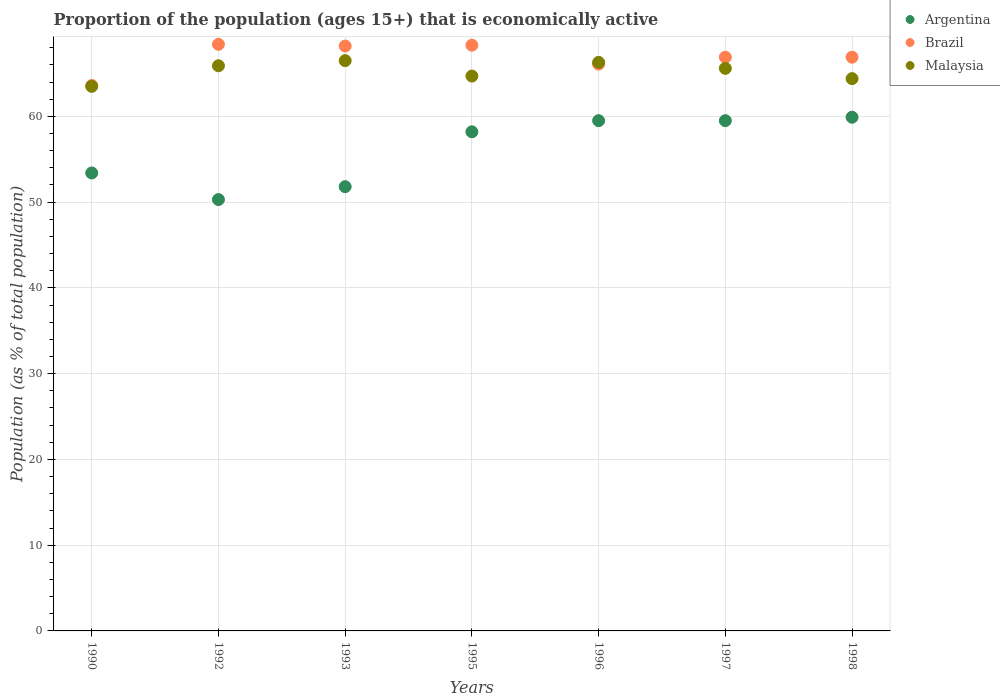Is the number of dotlines equal to the number of legend labels?
Give a very brief answer. Yes. What is the proportion of the population that is economically active in Malaysia in 1995?
Offer a terse response. 64.7. Across all years, what is the maximum proportion of the population that is economically active in Brazil?
Provide a short and direct response. 68.4. Across all years, what is the minimum proportion of the population that is economically active in Brazil?
Offer a very short reply. 63.6. In which year was the proportion of the population that is economically active in Malaysia minimum?
Make the answer very short. 1990. What is the total proportion of the population that is economically active in Brazil in the graph?
Your answer should be compact. 468.4. What is the difference between the proportion of the population that is economically active in Argentina in 1990 and that in 1995?
Your answer should be compact. -4.8. What is the difference between the proportion of the population that is economically active in Malaysia in 1993 and the proportion of the population that is economically active in Argentina in 1990?
Provide a succinct answer. 13.1. What is the average proportion of the population that is economically active in Brazil per year?
Offer a terse response. 66.91. In the year 1995, what is the difference between the proportion of the population that is economically active in Brazil and proportion of the population that is economically active in Malaysia?
Provide a succinct answer. 3.6. In how many years, is the proportion of the population that is economically active in Argentina greater than 64 %?
Offer a terse response. 0. What is the ratio of the proportion of the population that is economically active in Argentina in 1995 to that in 1996?
Give a very brief answer. 0.98. Is the difference between the proportion of the population that is economically active in Brazil in 1995 and 1996 greater than the difference between the proportion of the population that is economically active in Malaysia in 1995 and 1996?
Offer a terse response. Yes. What is the difference between the highest and the second highest proportion of the population that is economically active in Malaysia?
Keep it short and to the point. 0.2. Is it the case that in every year, the sum of the proportion of the population that is economically active in Malaysia and proportion of the population that is economically active in Argentina  is greater than the proportion of the population that is economically active in Brazil?
Your response must be concise. Yes. Does the proportion of the population that is economically active in Argentina monotonically increase over the years?
Your answer should be compact. No. Is the proportion of the population that is economically active in Malaysia strictly greater than the proportion of the population that is economically active in Argentina over the years?
Give a very brief answer. Yes. How many dotlines are there?
Make the answer very short. 3. Does the graph contain any zero values?
Offer a very short reply. No. How many legend labels are there?
Ensure brevity in your answer.  3. What is the title of the graph?
Make the answer very short. Proportion of the population (ages 15+) that is economically active. What is the label or title of the Y-axis?
Ensure brevity in your answer.  Population (as % of total population). What is the Population (as % of total population) in Argentina in 1990?
Make the answer very short. 53.4. What is the Population (as % of total population) of Brazil in 1990?
Keep it short and to the point. 63.6. What is the Population (as % of total population) in Malaysia in 1990?
Ensure brevity in your answer.  63.5. What is the Population (as % of total population) of Argentina in 1992?
Provide a short and direct response. 50.3. What is the Population (as % of total population) in Brazil in 1992?
Provide a succinct answer. 68.4. What is the Population (as % of total population) in Malaysia in 1992?
Offer a very short reply. 65.9. What is the Population (as % of total population) of Argentina in 1993?
Provide a succinct answer. 51.8. What is the Population (as % of total population) of Brazil in 1993?
Your answer should be very brief. 68.2. What is the Population (as % of total population) of Malaysia in 1993?
Provide a succinct answer. 66.5. What is the Population (as % of total population) in Argentina in 1995?
Ensure brevity in your answer.  58.2. What is the Population (as % of total population) of Brazil in 1995?
Give a very brief answer. 68.3. What is the Population (as % of total population) of Malaysia in 1995?
Give a very brief answer. 64.7. What is the Population (as % of total population) of Argentina in 1996?
Keep it short and to the point. 59.5. What is the Population (as % of total population) of Brazil in 1996?
Offer a terse response. 66.1. What is the Population (as % of total population) in Malaysia in 1996?
Make the answer very short. 66.3. What is the Population (as % of total population) in Argentina in 1997?
Provide a short and direct response. 59.5. What is the Population (as % of total population) in Brazil in 1997?
Your response must be concise. 66.9. What is the Population (as % of total population) in Malaysia in 1997?
Ensure brevity in your answer.  65.6. What is the Population (as % of total population) in Argentina in 1998?
Keep it short and to the point. 59.9. What is the Population (as % of total population) in Brazil in 1998?
Your response must be concise. 66.9. What is the Population (as % of total population) in Malaysia in 1998?
Provide a succinct answer. 64.4. Across all years, what is the maximum Population (as % of total population) in Argentina?
Give a very brief answer. 59.9. Across all years, what is the maximum Population (as % of total population) of Brazil?
Provide a short and direct response. 68.4. Across all years, what is the maximum Population (as % of total population) of Malaysia?
Ensure brevity in your answer.  66.5. Across all years, what is the minimum Population (as % of total population) in Argentina?
Offer a very short reply. 50.3. Across all years, what is the minimum Population (as % of total population) of Brazil?
Your answer should be very brief. 63.6. Across all years, what is the minimum Population (as % of total population) of Malaysia?
Give a very brief answer. 63.5. What is the total Population (as % of total population) of Argentina in the graph?
Ensure brevity in your answer.  392.6. What is the total Population (as % of total population) of Brazil in the graph?
Provide a short and direct response. 468.4. What is the total Population (as % of total population) in Malaysia in the graph?
Offer a very short reply. 456.9. What is the difference between the Population (as % of total population) of Argentina in 1990 and that in 1992?
Provide a succinct answer. 3.1. What is the difference between the Population (as % of total population) of Brazil in 1990 and that in 1992?
Provide a short and direct response. -4.8. What is the difference between the Population (as % of total population) in Malaysia in 1990 and that in 1992?
Offer a terse response. -2.4. What is the difference between the Population (as % of total population) in Argentina in 1990 and that in 1993?
Your answer should be compact. 1.6. What is the difference between the Population (as % of total population) of Argentina in 1990 and that in 1995?
Your answer should be very brief. -4.8. What is the difference between the Population (as % of total population) in Argentina in 1990 and that in 1996?
Ensure brevity in your answer.  -6.1. What is the difference between the Population (as % of total population) of Argentina in 1990 and that in 1997?
Ensure brevity in your answer.  -6.1. What is the difference between the Population (as % of total population) of Brazil in 1990 and that in 1997?
Your answer should be very brief. -3.3. What is the difference between the Population (as % of total population) of Malaysia in 1990 and that in 1997?
Your response must be concise. -2.1. What is the difference between the Population (as % of total population) of Argentina in 1992 and that in 1993?
Your response must be concise. -1.5. What is the difference between the Population (as % of total population) of Argentina in 1992 and that in 1995?
Offer a very short reply. -7.9. What is the difference between the Population (as % of total population) in Brazil in 1992 and that in 1995?
Ensure brevity in your answer.  0.1. What is the difference between the Population (as % of total population) in Malaysia in 1992 and that in 1995?
Offer a terse response. 1.2. What is the difference between the Population (as % of total population) in Brazil in 1992 and that in 1996?
Offer a very short reply. 2.3. What is the difference between the Population (as % of total population) of Argentina in 1992 and that in 1997?
Your response must be concise. -9.2. What is the difference between the Population (as % of total population) of Brazil in 1992 and that in 1997?
Your response must be concise. 1.5. What is the difference between the Population (as % of total population) of Brazil in 1992 and that in 1998?
Make the answer very short. 1.5. What is the difference between the Population (as % of total population) of Malaysia in 1992 and that in 1998?
Provide a succinct answer. 1.5. What is the difference between the Population (as % of total population) in Argentina in 1993 and that in 1995?
Offer a terse response. -6.4. What is the difference between the Population (as % of total population) of Brazil in 1993 and that in 1995?
Offer a terse response. -0.1. What is the difference between the Population (as % of total population) in Malaysia in 1993 and that in 1995?
Your answer should be very brief. 1.8. What is the difference between the Population (as % of total population) in Argentina in 1993 and that in 1997?
Provide a short and direct response. -7.7. What is the difference between the Population (as % of total population) of Brazil in 1993 and that in 1997?
Keep it short and to the point. 1.3. What is the difference between the Population (as % of total population) of Brazil in 1993 and that in 1998?
Your response must be concise. 1.3. What is the difference between the Population (as % of total population) in Malaysia in 1995 and that in 1996?
Offer a very short reply. -1.6. What is the difference between the Population (as % of total population) in Argentina in 1995 and that in 1997?
Your answer should be compact. -1.3. What is the difference between the Population (as % of total population) in Malaysia in 1995 and that in 1997?
Your response must be concise. -0.9. What is the difference between the Population (as % of total population) in Brazil in 1995 and that in 1998?
Your response must be concise. 1.4. What is the difference between the Population (as % of total population) of Malaysia in 1995 and that in 1998?
Offer a terse response. 0.3. What is the difference between the Population (as % of total population) of Argentina in 1996 and that in 1997?
Your answer should be very brief. 0. What is the difference between the Population (as % of total population) in Malaysia in 1996 and that in 1997?
Provide a short and direct response. 0.7. What is the difference between the Population (as % of total population) in Argentina in 1996 and that in 1998?
Provide a succinct answer. -0.4. What is the difference between the Population (as % of total population) in Malaysia in 1996 and that in 1998?
Provide a succinct answer. 1.9. What is the difference between the Population (as % of total population) of Argentina in 1997 and that in 1998?
Your answer should be very brief. -0.4. What is the difference between the Population (as % of total population) of Brazil in 1997 and that in 1998?
Ensure brevity in your answer.  0. What is the difference between the Population (as % of total population) in Argentina in 1990 and the Population (as % of total population) in Brazil in 1992?
Your response must be concise. -15. What is the difference between the Population (as % of total population) in Argentina in 1990 and the Population (as % of total population) in Malaysia in 1992?
Offer a terse response. -12.5. What is the difference between the Population (as % of total population) in Argentina in 1990 and the Population (as % of total population) in Brazil in 1993?
Give a very brief answer. -14.8. What is the difference between the Population (as % of total population) in Argentina in 1990 and the Population (as % of total population) in Malaysia in 1993?
Offer a very short reply. -13.1. What is the difference between the Population (as % of total population) of Argentina in 1990 and the Population (as % of total population) of Brazil in 1995?
Make the answer very short. -14.9. What is the difference between the Population (as % of total population) in Argentina in 1990 and the Population (as % of total population) in Brazil in 1997?
Offer a very short reply. -13.5. What is the difference between the Population (as % of total population) in Argentina in 1990 and the Population (as % of total population) in Malaysia in 1997?
Ensure brevity in your answer.  -12.2. What is the difference between the Population (as % of total population) of Brazil in 1990 and the Population (as % of total population) of Malaysia in 1997?
Provide a succinct answer. -2. What is the difference between the Population (as % of total population) of Argentina in 1990 and the Population (as % of total population) of Brazil in 1998?
Make the answer very short. -13.5. What is the difference between the Population (as % of total population) of Argentina in 1992 and the Population (as % of total population) of Brazil in 1993?
Your answer should be compact. -17.9. What is the difference between the Population (as % of total population) in Argentina in 1992 and the Population (as % of total population) in Malaysia in 1993?
Provide a succinct answer. -16.2. What is the difference between the Population (as % of total population) in Argentina in 1992 and the Population (as % of total population) in Malaysia in 1995?
Provide a short and direct response. -14.4. What is the difference between the Population (as % of total population) in Argentina in 1992 and the Population (as % of total population) in Brazil in 1996?
Your answer should be compact. -15.8. What is the difference between the Population (as % of total population) in Brazil in 1992 and the Population (as % of total population) in Malaysia in 1996?
Keep it short and to the point. 2.1. What is the difference between the Population (as % of total population) of Argentina in 1992 and the Population (as % of total population) of Brazil in 1997?
Your answer should be very brief. -16.6. What is the difference between the Population (as % of total population) in Argentina in 1992 and the Population (as % of total population) in Malaysia in 1997?
Your answer should be compact. -15.3. What is the difference between the Population (as % of total population) of Argentina in 1992 and the Population (as % of total population) of Brazil in 1998?
Keep it short and to the point. -16.6. What is the difference between the Population (as % of total population) in Argentina in 1992 and the Population (as % of total population) in Malaysia in 1998?
Offer a terse response. -14.1. What is the difference between the Population (as % of total population) in Brazil in 1992 and the Population (as % of total population) in Malaysia in 1998?
Keep it short and to the point. 4. What is the difference between the Population (as % of total population) in Argentina in 1993 and the Population (as % of total population) in Brazil in 1995?
Offer a terse response. -16.5. What is the difference between the Population (as % of total population) in Argentina in 1993 and the Population (as % of total population) in Malaysia in 1995?
Offer a very short reply. -12.9. What is the difference between the Population (as % of total population) in Argentina in 1993 and the Population (as % of total population) in Brazil in 1996?
Provide a succinct answer. -14.3. What is the difference between the Population (as % of total population) of Brazil in 1993 and the Population (as % of total population) of Malaysia in 1996?
Offer a terse response. 1.9. What is the difference between the Population (as % of total population) of Argentina in 1993 and the Population (as % of total population) of Brazil in 1997?
Ensure brevity in your answer.  -15.1. What is the difference between the Population (as % of total population) in Argentina in 1993 and the Population (as % of total population) in Malaysia in 1997?
Your answer should be very brief. -13.8. What is the difference between the Population (as % of total population) in Brazil in 1993 and the Population (as % of total population) in Malaysia in 1997?
Give a very brief answer. 2.6. What is the difference between the Population (as % of total population) of Argentina in 1993 and the Population (as % of total population) of Brazil in 1998?
Provide a short and direct response. -15.1. What is the difference between the Population (as % of total population) of Brazil in 1993 and the Population (as % of total population) of Malaysia in 1998?
Your answer should be compact. 3.8. What is the difference between the Population (as % of total population) in Argentina in 1995 and the Population (as % of total population) in Brazil in 1996?
Ensure brevity in your answer.  -7.9. What is the difference between the Population (as % of total population) in Argentina in 1995 and the Population (as % of total population) in Malaysia in 1996?
Make the answer very short. -8.1. What is the difference between the Population (as % of total population) in Argentina in 1995 and the Population (as % of total population) in Brazil in 1997?
Your response must be concise. -8.7. What is the difference between the Population (as % of total population) of Brazil in 1995 and the Population (as % of total population) of Malaysia in 1998?
Offer a very short reply. 3.9. What is the difference between the Population (as % of total population) of Argentina in 1996 and the Population (as % of total population) of Brazil in 1997?
Your answer should be compact. -7.4. What is the difference between the Population (as % of total population) in Brazil in 1996 and the Population (as % of total population) in Malaysia in 1997?
Give a very brief answer. 0.5. What is the difference between the Population (as % of total population) in Argentina in 1996 and the Population (as % of total population) in Brazil in 1998?
Offer a terse response. -7.4. What is the difference between the Population (as % of total population) of Brazil in 1996 and the Population (as % of total population) of Malaysia in 1998?
Offer a terse response. 1.7. What is the difference between the Population (as % of total population) in Argentina in 1997 and the Population (as % of total population) in Malaysia in 1998?
Keep it short and to the point. -4.9. What is the average Population (as % of total population) of Argentina per year?
Your answer should be compact. 56.09. What is the average Population (as % of total population) in Brazil per year?
Your answer should be very brief. 66.91. What is the average Population (as % of total population) of Malaysia per year?
Your response must be concise. 65.27. In the year 1990, what is the difference between the Population (as % of total population) in Argentina and Population (as % of total population) in Brazil?
Keep it short and to the point. -10.2. In the year 1990, what is the difference between the Population (as % of total population) in Argentina and Population (as % of total population) in Malaysia?
Offer a terse response. -10.1. In the year 1990, what is the difference between the Population (as % of total population) of Brazil and Population (as % of total population) of Malaysia?
Your answer should be very brief. 0.1. In the year 1992, what is the difference between the Population (as % of total population) of Argentina and Population (as % of total population) of Brazil?
Give a very brief answer. -18.1. In the year 1992, what is the difference between the Population (as % of total population) in Argentina and Population (as % of total population) in Malaysia?
Offer a terse response. -15.6. In the year 1993, what is the difference between the Population (as % of total population) of Argentina and Population (as % of total population) of Brazil?
Offer a very short reply. -16.4. In the year 1993, what is the difference between the Population (as % of total population) in Argentina and Population (as % of total population) in Malaysia?
Provide a short and direct response. -14.7. In the year 1995, what is the difference between the Population (as % of total population) in Argentina and Population (as % of total population) in Brazil?
Offer a very short reply. -10.1. In the year 1995, what is the difference between the Population (as % of total population) of Brazil and Population (as % of total population) of Malaysia?
Provide a succinct answer. 3.6. In the year 1996, what is the difference between the Population (as % of total population) of Argentina and Population (as % of total population) of Brazil?
Make the answer very short. -6.6. In the year 1996, what is the difference between the Population (as % of total population) of Argentina and Population (as % of total population) of Malaysia?
Offer a terse response. -6.8. In the year 1996, what is the difference between the Population (as % of total population) in Brazil and Population (as % of total population) in Malaysia?
Give a very brief answer. -0.2. In the year 1997, what is the difference between the Population (as % of total population) of Argentina and Population (as % of total population) of Brazil?
Your answer should be very brief. -7.4. In the year 1997, what is the difference between the Population (as % of total population) of Argentina and Population (as % of total population) of Malaysia?
Your answer should be very brief. -6.1. In the year 1997, what is the difference between the Population (as % of total population) in Brazil and Population (as % of total population) in Malaysia?
Your response must be concise. 1.3. In the year 1998, what is the difference between the Population (as % of total population) in Argentina and Population (as % of total population) in Malaysia?
Ensure brevity in your answer.  -4.5. In the year 1998, what is the difference between the Population (as % of total population) in Brazil and Population (as % of total population) in Malaysia?
Your answer should be very brief. 2.5. What is the ratio of the Population (as % of total population) of Argentina in 1990 to that in 1992?
Provide a succinct answer. 1.06. What is the ratio of the Population (as % of total population) of Brazil in 1990 to that in 1992?
Offer a very short reply. 0.93. What is the ratio of the Population (as % of total population) in Malaysia in 1990 to that in 1992?
Ensure brevity in your answer.  0.96. What is the ratio of the Population (as % of total population) in Argentina in 1990 to that in 1993?
Your answer should be compact. 1.03. What is the ratio of the Population (as % of total population) of Brazil in 1990 to that in 1993?
Make the answer very short. 0.93. What is the ratio of the Population (as % of total population) in Malaysia in 1990 to that in 1993?
Provide a short and direct response. 0.95. What is the ratio of the Population (as % of total population) in Argentina in 1990 to that in 1995?
Make the answer very short. 0.92. What is the ratio of the Population (as % of total population) of Brazil in 1990 to that in 1995?
Your answer should be compact. 0.93. What is the ratio of the Population (as % of total population) in Malaysia in 1990 to that in 1995?
Provide a short and direct response. 0.98. What is the ratio of the Population (as % of total population) of Argentina in 1990 to that in 1996?
Make the answer very short. 0.9. What is the ratio of the Population (as % of total population) in Brazil in 1990 to that in 1996?
Your answer should be compact. 0.96. What is the ratio of the Population (as % of total population) of Malaysia in 1990 to that in 1996?
Ensure brevity in your answer.  0.96. What is the ratio of the Population (as % of total population) in Argentina in 1990 to that in 1997?
Ensure brevity in your answer.  0.9. What is the ratio of the Population (as % of total population) in Brazil in 1990 to that in 1997?
Your response must be concise. 0.95. What is the ratio of the Population (as % of total population) in Argentina in 1990 to that in 1998?
Provide a succinct answer. 0.89. What is the ratio of the Population (as % of total population) in Brazil in 1990 to that in 1998?
Ensure brevity in your answer.  0.95. What is the ratio of the Population (as % of total population) of Argentina in 1992 to that in 1993?
Your answer should be compact. 0.97. What is the ratio of the Population (as % of total population) of Malaysia in 1992 to that in 1993?
Your answer should be compact. 0.99. What is the ratio of the Population (as % of total population) in Argentina in 1992 to that in 1995?
Provide a succinct answer. 0.86. What is the ratio of the Population (as % of total population) of Malaysia in 1992 to that in 1995?
Your answer should be very brief. 1.02. What is the ratio of the Population (as % of total population) in Argentina in 1992 to that in 1996?
Provide a short and direct response. 0.85. What is the ratio of the Population (as % of total population) of Brazil in 1992 to that in 1996?
Your answer should be very brief. 1.03. What is the ratio of the Population (as % of total population) of Argentina in 1992 to that in 1997?
Offer a very short reply. 0.85. What is the ratio of the Population (as % of total population) of Brazil in 1992 to that in 1997?
Your answer should be compact. 1.02. What is the ratio of the Population (as % of total population) of Malaysia in 1992 to that in 1997?
Give a very brief answer. 1. What is the ratio of the Population (as % of total population) of Argentina in 1992 to that in 1998?
Give a very brief answer. 0.84. What is the ratio of the Population (as % of total population) in Brazil in 1992 to that in 1998?
Give a very brief answer. 1.02. What is the ratio of the Population (as % of total population) in Malaysia in 1992 to that in 1998?
Keep it short and to the point. 1.02. What is the ratio of the Population (as % of total population) in Argentina in 1993 to that in 1995?
Your response must be concise. 0.89. What is the ratio of the Population (as % of total population) in Malaysia in 1993 to that in 1995?
Offer a terse response. 1.03. What is the ratio of the Population (as % of total population) of Argentina in 1993 to that in 1996?
Give a very brief answer. 0.87. What is the ratio of the Population (as % of total population) of Brazil in 1993 to that in 1996?
Ensure brevity in your answer.  1.03. What is the ratio of the Population (as % of total population) of Argentina in 1993 to that in 1997?
Your answer should be compact. 0.87. What is the ratio of the Population (as % of total population) in Brazil in 1993 to that in 1997?
Your answer should be compact. 1.02. What is the ratio of the Population (as % of total population) of Malaysia in 1993 to that in 1997?
Your response must be concise. 1.01. What is the ratio of the Population (as % of total population) in Argentina in 1993 to that in 1998?
Offer a very short reply. 0.86. What is the ratio of the Population (as % of total population) of Brazil in 1993 to that in 1998?
Your answer should be very brief. 1.02. What is the ratio of the Population (as % of total population) in Malaysia in 1993 to that in 1998?
Give a very brief answer. 1.03. What is the ratio of the Population (as % of total population) of Argentina in 1995 to that in 1996?
Offer a terse response. 0.98. What is the ratio of the Population (as % of total population) of Malaysia in 1995 to that in 1996?
Ensure brevity in your answer.  0.98. What is the ratio of the Population (as % of total population) of Argentina in 1995 to that in 1997?
Keep it short and to the point. 0.98. What is the ratio of the Population (as % of total population) in Brazil in 1995 to that in 1997?
Give a very brief answer. 1.02. What is the ratio of the Population (as % of total population) of Malaysia in 1995 to that in 1997?
Your answer should be compact. 0.99. What is the ratio of the Population (as % of total population) of Argentina in 1995 to that in 1998?
Your answer should be very brief. 0.97. What is the ratio of the Population (as % of total population) of Brazil in 1995 to that in 1998?
Offer a terse response. 1.02. What is the ratio of the Population (as % of total population) in Malaysia in 1995 to that in 1998?
Make the answer very short. 1. What is the ratio of the Population (as % of total population) of Argentina in 1996 to that in 1997?
Ensure brevity in your answer.  1. What is the ratio of the Population (as % of total population) in Brazil in 1996 to that in 1997?
Your answer should be very brief. 0.99. What is the ratio of the Population (as % of total population) of Malaysia in 1996 to that in 1997?
Give a very brief answer. 1.01. What is the ratio of the Population (as % of total population) in Malaysia in 1996 to that in 1998?
Give a very brief answer. 1.03. What is the ratio of the Population (as % of total population) in Malaysia in 1997 to that in 1998?
Your response must be concise. 1.02. What is the difference between the highest and the second highest Population (as % of total population) of Argentina?
Provide a short and direct response. 0.4. What is the difference between the highest and the second highest Population (as % of total population) of Brazil?
Your answer should be compact. 0.1. What is the difference between the highest and the second highest Population (as % of total population) in Malaysia?
Your answer should be very brief. 0.2. What is the difference between the highest and the lowest Population (as % of total population) in Argentina?
Ensure brevity in your answer.  9.6. 